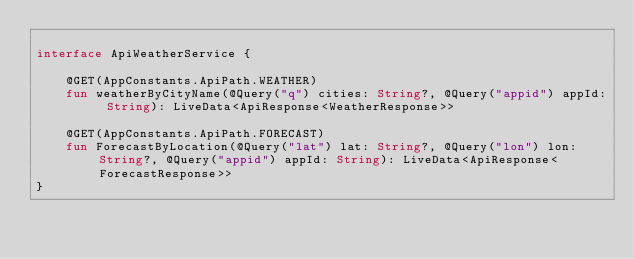<code> <loc_0><loc_0><loc_500><loc_500><_Kotlin_>
interface ApiWeatherService {

    @GET(AppConstants.ApiPath.WEATHER)
    fun weatherByCityName(@Query("q") cities: String?, @Query("appid") appId: String): LiveData<ApiResponse<WeatherResponse>>

    @GET(AppConstants.ApiPath.FORECAST)
    fun ForecastByLocation(@Query("lat") lat: String?, @Query("lon") lon: String?, @Query("appid") appId: String): LiveData<ApiResponse<ForecastResponse>>
}</code> 